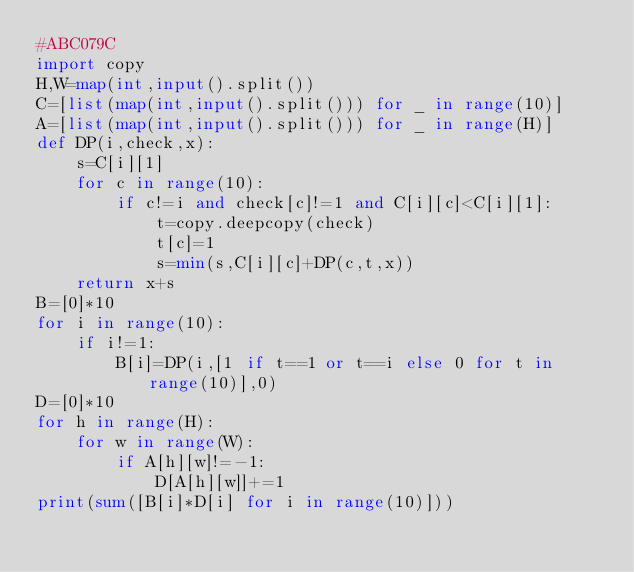Convert code to text. <code><loc_0><loc_0><loc_500><loc_500><_Python_>#ABC079C
import copy
H,W=map(int,input().split())
C=[list(map(int,input().split())) for _ in range(10)]
A=[list(map(int,input().split())) for _ in range(H)]
def DP(i,check,x):
    s=C[i][1]
    for c in range(10):
        if c!=i and check[c]!=1 and C[i][c]<C[i][1]:
            t=copy.deepcopy(check)
            t[c]=1
            s=min(s,C[i][c]+DP(c,t,x))
    return x+s
B=[0]*10
for i in range(10):
    if i!=1:
        B[i]=DP(i,[1 if t==1 or t==i else 0 for t in range(10)],0)
D=[0]*10
for h in range(H):
    for w in range(W):
        if A[h][w]!=-1:
            D[A[h][w]]+=1
print(sum([B[i]*D[i] for i in range(10)]))</code> 